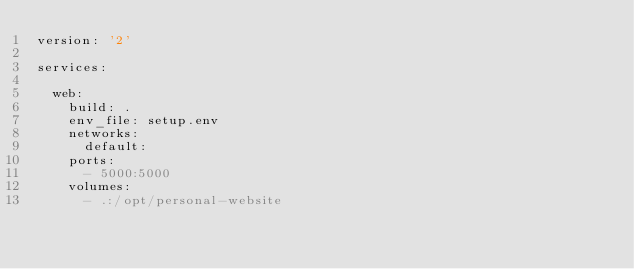Convert code to text. <code><loc_0><loc_0><loc_500><loc_500><_YAML_>version: '2'

services:

  web:
    build: .
    env_file: setup.env
    networks:
      default:
    ports:
      - 5000:5000
    volumes:
      - .:/opt/personal-website


</code> 